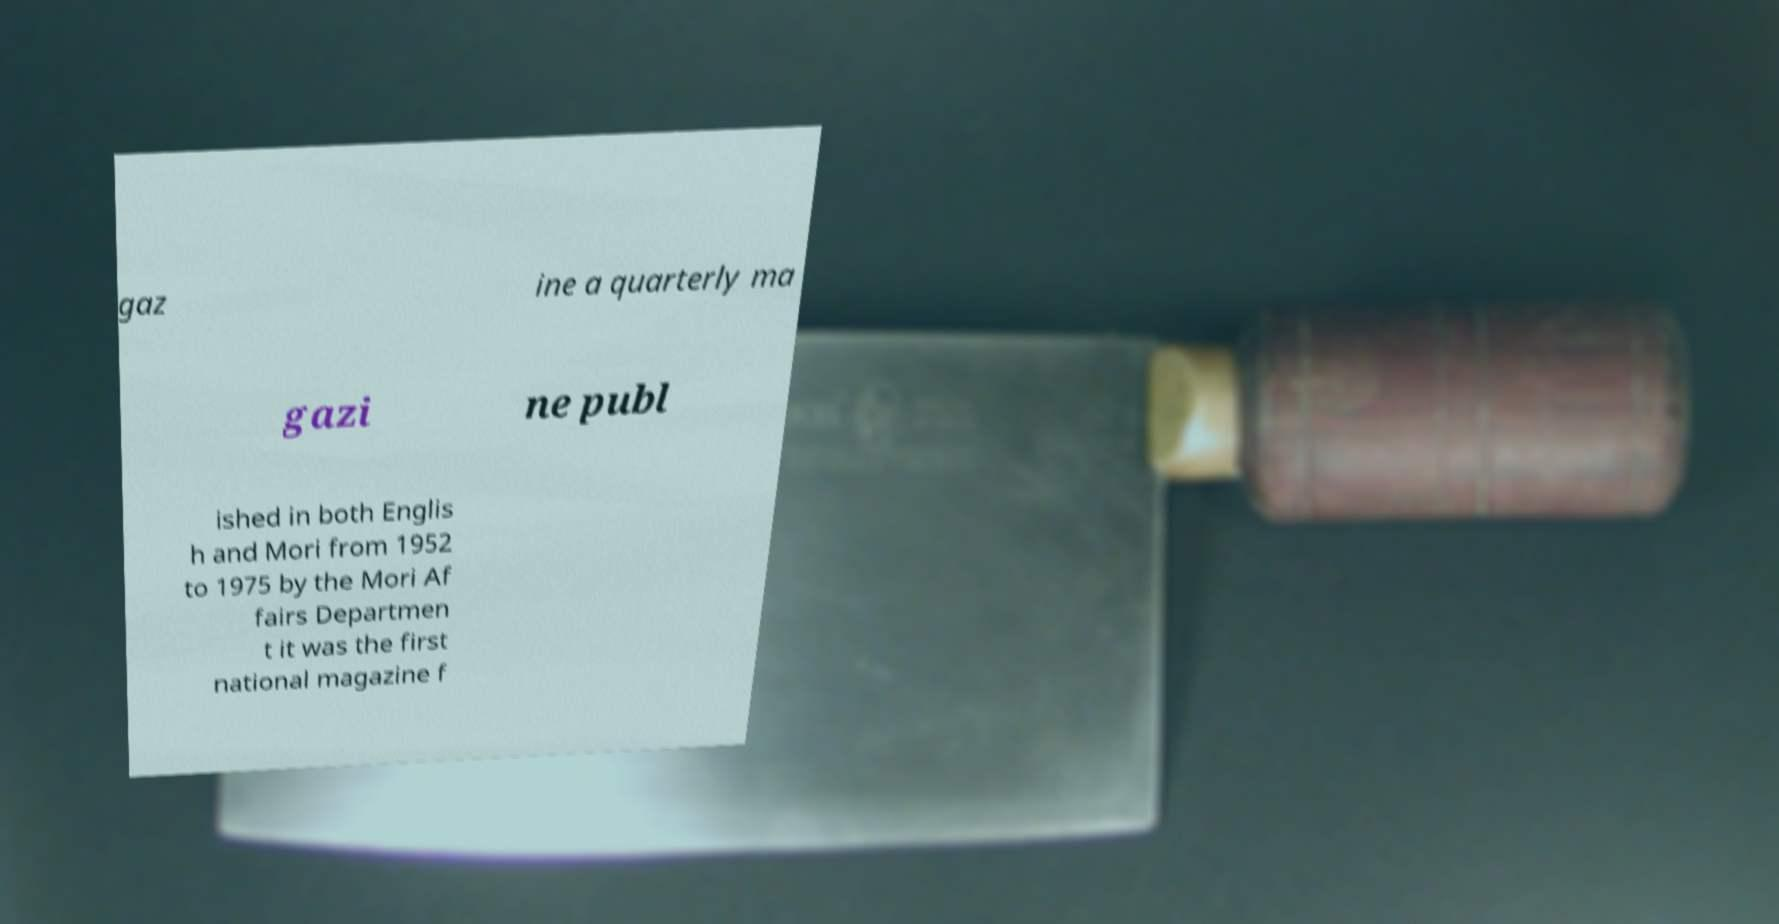Could you assist in decoding the text presented in this image and type it out clearly? gaz ine a quarterly ma gazi ne publ ished in both Englis h and Mori from 1952 to 1975 by the Mori Af fairs Departmen t it was the first national magazine f 